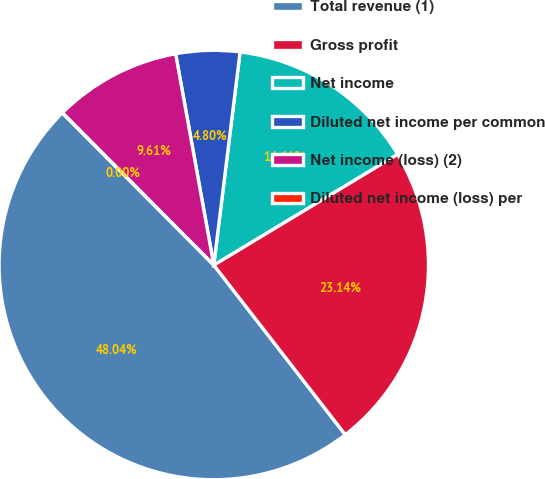Convert chart. <chart><loc_0><loc_0><loc_500><loc_500><pie_chart><fcel>Total revenue (1)<fcel>Gross profit<fcel>Net income<fcel>Diluted net income per common<fcel>Net income (loss) (2)<fcel>Diluted net income (loss) per<nl><fcel>48.04%<fcel>23.14%<fcel>14.41%<fcel>4.8%<fcel>9.61%<fcel>0.0%<nl></chart> 